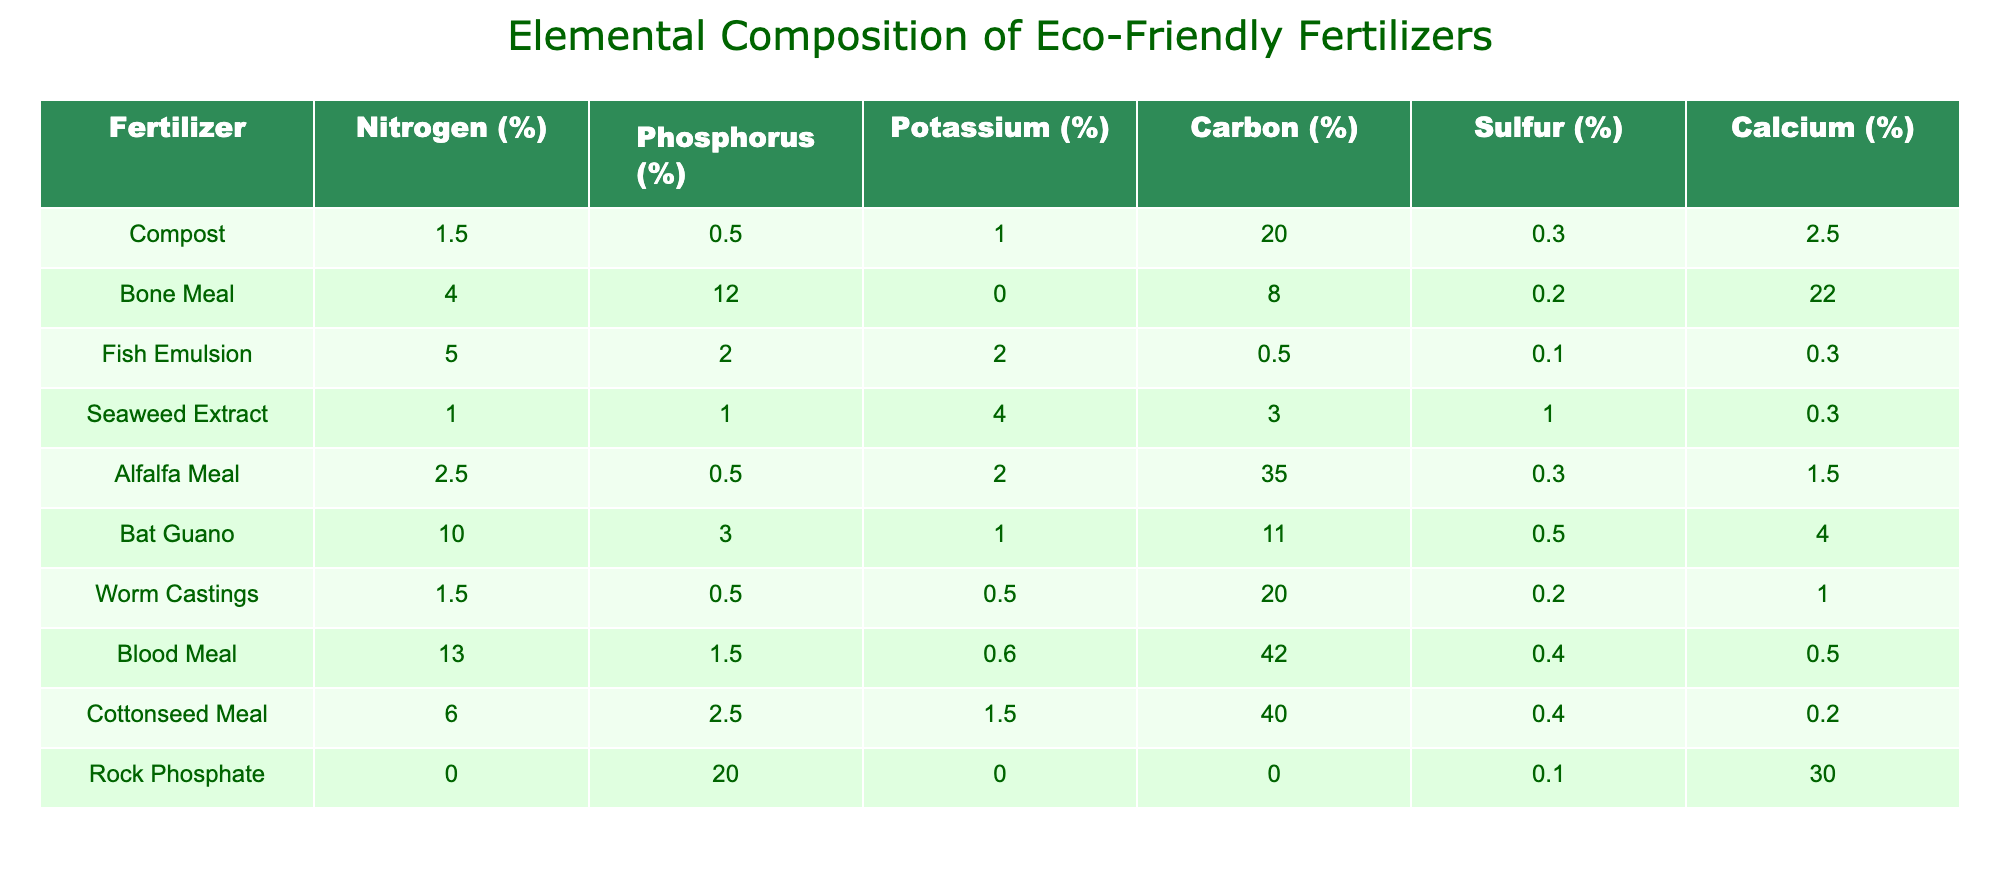What is the nitrogen percentage in Bone Meal? Referring to the table, the nitrogen percentage for Bone Meal is specifically listed under the Nitrogen (%) column next to its name. The value is 4.0%.
Answer: 4.0% Which fertilizer has the highest phosphorus content? By scanning the Phosphorus (%) column, Rock Phosphate has the highest value at 20.0%, making it the fertilizer with the most phosphorus.
Answer: Rock Phosphate What is the total potassium percentage of Fish Emulsion and Seaweed Extract combined? To find the total potassium percentage, add the potassium values of Fish Emulsion (2.0%) and Seaweed Extract (4.0%): 2.0 + 4.0 = 6.0%.
Answer: 6.0% Is the sulfur content in Blood Meal greater than the sulfur content in Worm Castings? Comparing the values in the Sulfur (%) column, Blood Meal has a sulfur content of 0.4%, while Worm Castings has 0.2%. Since 0.4% is greater than 0.2%, the statement is true.
Answer: Yes What is the average carbon percentage in Compost and Alfalfa Meal? Calculate the average by adding the carbon values for Compost (20.0%) and Alfalfa Meal (35.0%): 20.0 + 35.0 = 55.0%. Divide by the number of fertilizers (2), resulting in an average of 55.0 / 2 = 27.5%.
Answer: 27.5% Which fertilizer contains no potassium at all? Looking through the table under the Potassium (%) column, Rock Phosphate shows a value of 0.0%, indicating it has no potassium.
Answer: Rock Phosphate What is the difference in nitrogen content between Bat Guano and Blood Meal? The nitrogen content in Bat Guano is 10.0% and in Blood Meal it is 13.0%. To find the difference, subtract Bat Guano's nitrogen from Blood Meal's: 13.0 - 10.0 = 3.0%.
Answer: 3.0% Are both Fish Emulsion and Alfalfa Meal low in phosphorus content? Checking the values in the Phosphorus (%) column: Fish Emulsion has 2.0% and Alfalfa Meal has 0.5%. Both values are relatively low compared to other fertilizers, indicating they are indeed low in phosphorus.
Answer: Yes What is the cumulative calcium percentage of Bone Meal, Rock Phosphate, and Blood Meal? To determine the cumulative calcium, add the calcium percentages: Bone Meal (22.0%) + Rock Phosphate (30.0%) + Blood Meal (0.5%) = 22.0 + 30.0 + 0.5 = 52.5%.
Answer: 52.5% 